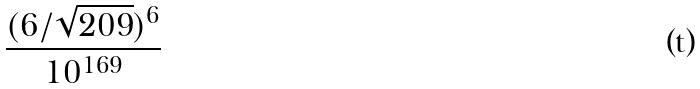<formula> <loc_0><loc_0><loc_500><loc_500>\frac { ( 6 / \sqrt { 2 0 9 } ) ^ { 6 } } { 1 0 ^ { 1 6 9 } }</formula> 